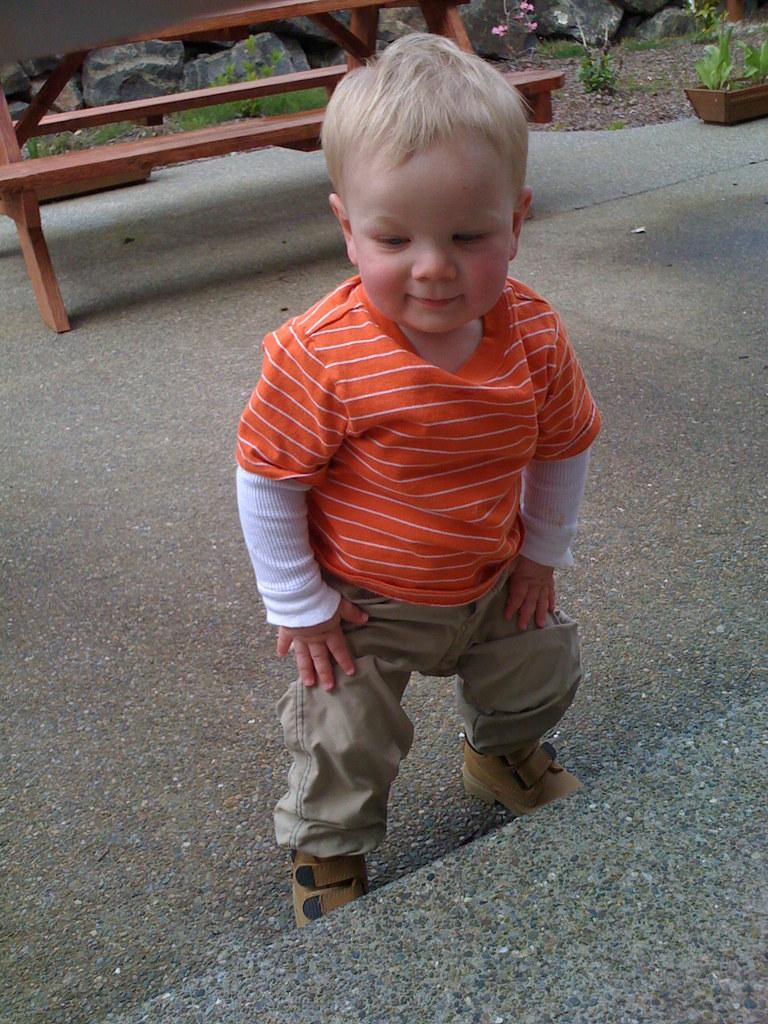What is the main subject of the image? There is a boy in the image. What is the boy doing in the image? The boy is standing on the ground and smiling. What can be seen in the background of the image? There is a bench, a house plant, and stones in the background of the image. What type of error can be seen in the image? There is no error present in the image. Is there any poison visible in the image? There is no poison present in the image. 